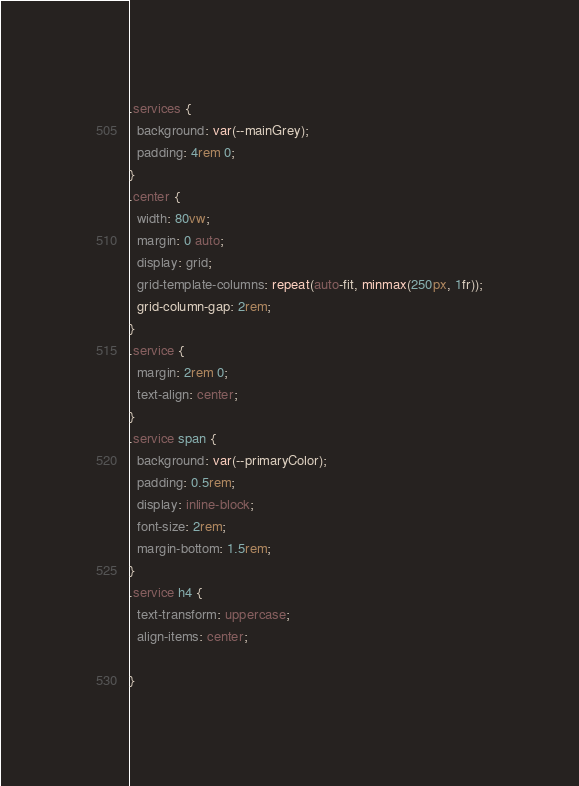Convert code to text. <code><loc_0><loc_0><loc_500><loc_500><_CSS_>.services {
  background: var(--mainGrey);
  padding: 4rem 0;
}
.center {
  width: 80vw;
  margin: 0 auto;
  display: grid;
  grid-template-columns: repeat(auto-fit, minmax(250px, 1fr));
  grid-column-gap: 2rem;
}
.service {
  margin: 2rem 0;
  text-align: center;
}
.service span {
  background: var(--primaryColor);
  padding: 0.5rem;
  display: inline-block;
  font-size: 2rem;
  margin-bottom: 1.5rem;
}
.service h4 {
  text-transform: uppercase;
  align-items: center;
  
}
</code> 